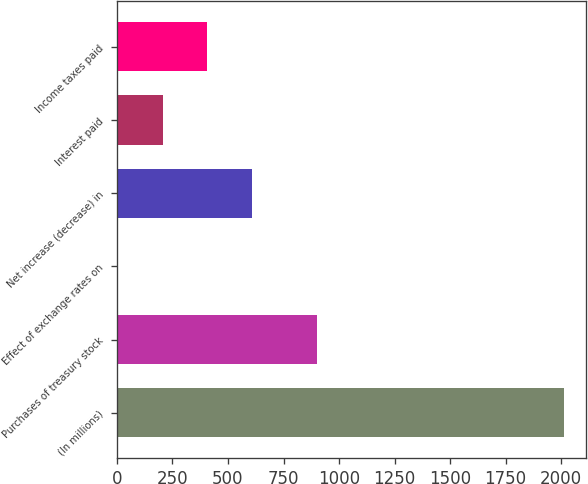Convert chart. <chart><loc_0><loc_0><loc_500><loc_500><bar_chart><fcel>(In millions)<fcel>Purchases of treasury stock<fcel>Effect of exchange rates on<fcel>Net increase (decrease) in<fcel>Interest paid<fcel>Income taxes paid<nl><fcel>2012<fcel>900<fcel>6<fcel>607.8<fcel>206.6<fcel>407.2<nl></chart> 